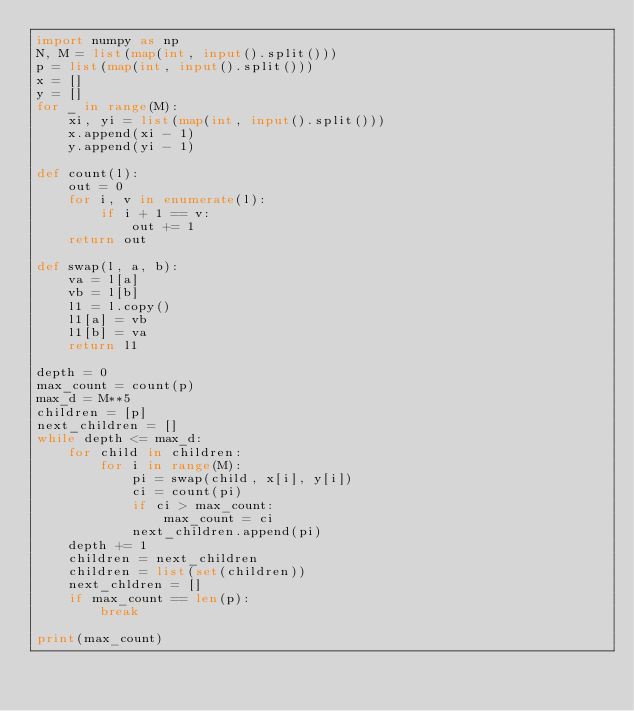<code> <loc_0><loc_0><loc_500><loc_500><_Python_>import numpy as np
N, M = list(map(int, input().split()))
p = list(map(int, input().split()))
x = []
y = []
for _ in range(M):
    xi, yi = list(map(int, input().split()))
    x.append(xi - 1)
    y.append(yi - 1)

def count(l):
    out = 0
    for i, v in enumerate(l):
        if i + 1 == v:
            out += 1
    return out

def swap(l, a, b):
    va = l[a]
    vb = l[b]
    l1 = l.copy()
    l1[a] = vb
    l1[b] = va
    return l1

depth = 0
max_count = count(p)
max_d = M**5
children = [p]
next_children = []
while depth <= max_d:
    for child in children:
        for i in range(M):
            pi = swap(child, x[i], y[i])
            ci = count(pi)
            if ci > max_count:
                max_count = ci
            next_children.append(pi)
    depth += 1
    children = next_children
    children = list(set(children))
    next_chldren = []
    if max_count == len(p):
        break

print(max_count)</code> 